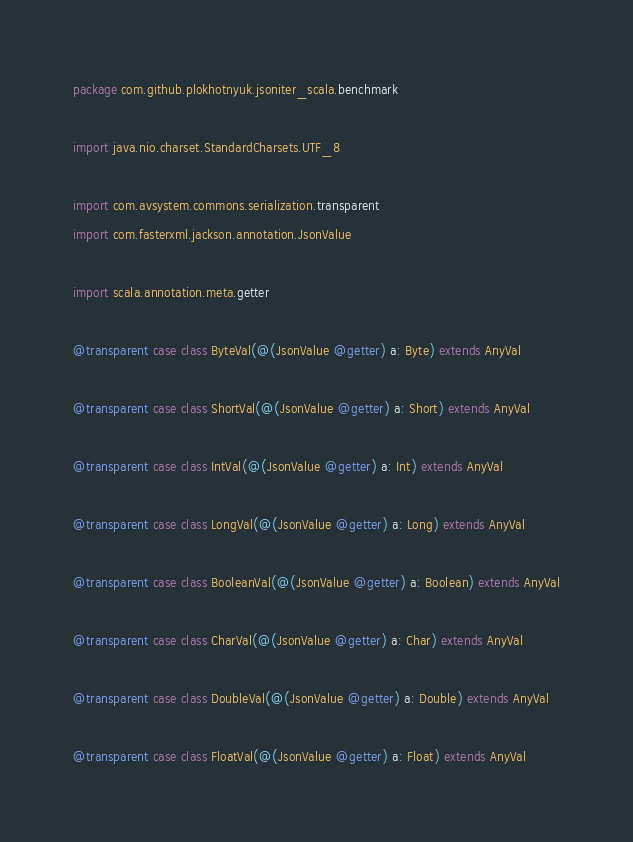Convert code to text. <code><loc_0><loc_0><loc_500><loc_500><_Scala_>package com.github.plokhotnyuk.jsoniter_scala.benchmark

import java.nio.charset.StandardCharsets.UTF_8

import com.avsystem.commons.serialization.transparent
import com.fasterxml.jackson.annotation.JsonValue

import scala.annotation.meta.getter

@transparent case class ByteVal(@(JsonValue @getter) a: Byte) extends AnyVal

@transparent case class ShortVal(@(JsonValue @getter) a: Short) extends AnyVal

@transparent case class IntVal(@(JsonValue @getter) a: Int) extends AnyVal

@transparent case class LongVal(@(JsonValue @getter) a: Long) extends AnyVal

@transparent case class BooleanVal(@(JsonValue @getter) a: Boolean) extends AnyVal

@transparent case class CharVal(@(JsonValue @getter) a: Char) extends AnyVal

@transparent case class DoubleVal(@(JsonValue @getter) a: Double) extends AnyVal

@transparent case class FloatVal(@(JsonValue @getter) a: Float) extends AnyVal
</code> 